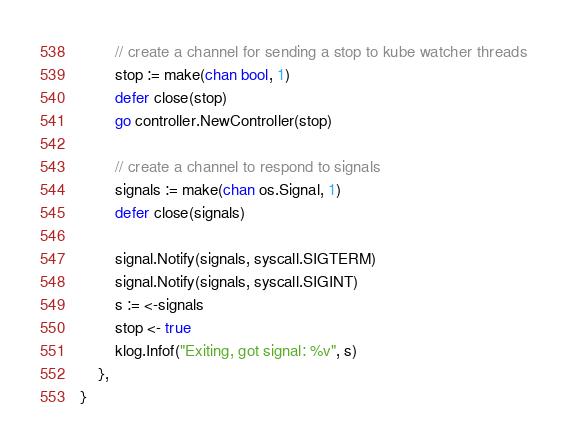Convert code to text. <code><loc_0><loc_0><loc_500><loc_500><_Go_>		// create a channel for sending a stop to kube watcher threads
		stop := make(chan bool, 1)
		defer close(stop)
		go controller.NewController(stop)

		// create a channel to respond to signals
		signals := make(chan os.Signal, 1)
		defer close(signals)

		signal.Notify(signals, syscall.SIGTERM)
		signal.Notify(signals, syscall.SIGINT)
		s := <-signals
		stop <- true
		klog.Infof("Exiting, got signal: %v", s)
	},
}
</code> 